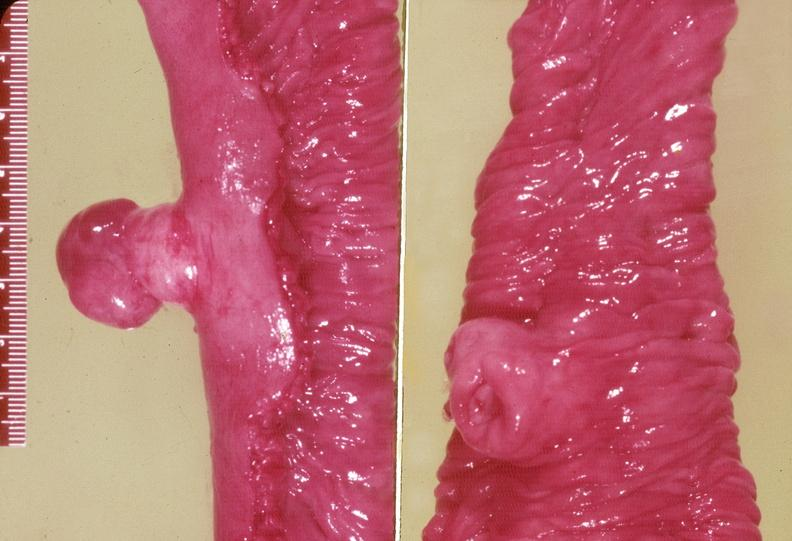what is present?
Answer the question using a single word or phrase. Gastrointestinal 